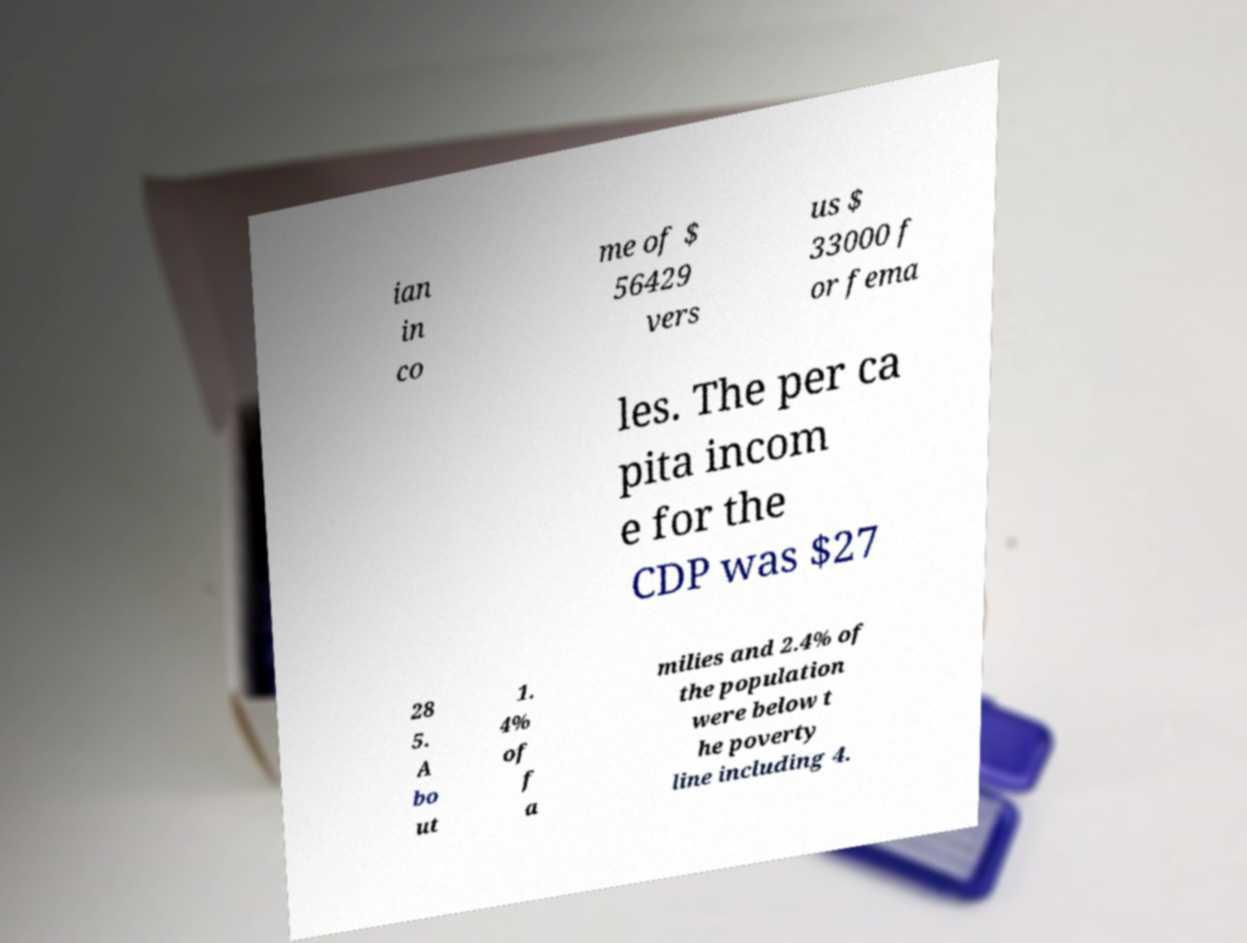Could you assist in decoding the text presented in this image and type it out clearly? ian in co me of $ 56429 vers us $ 33000 f or fema les. The per ca pita incom e for the CDP was $27 28 5. A bo ut 1. 4% of f a milies and 2.4% of the population were below t he poverty line including 4. 